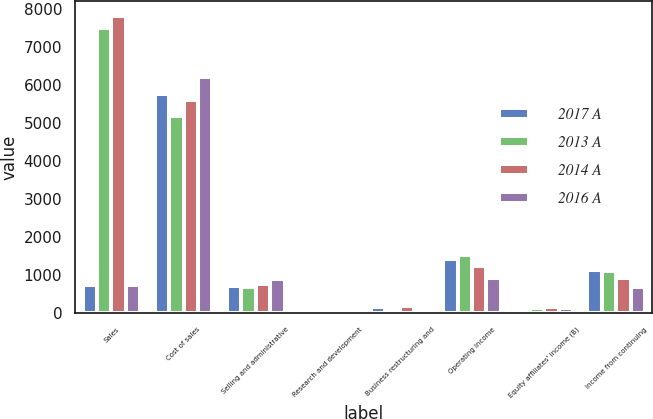Convert chart to OTSL. <chart><loc_0><loc_0><loc_500><loc_500><stacked_bar_chart><ecel><fcel>Sales<fcel>Cost of sales<fcel>Selling and administrative<fcel>Research and development<fcel>Business restructuring and<fcel>Operating income<fcel>Equity affiliates' income (B)<fcel>Income from continuing<nl><fcel>2017 A<fcel>744.5<fcel>5753<fcel>716<fcel>58<fcel>151<fcel>1428<fcel>80<fcel>1134<nl><fcel>2013 A<fcel>7504<fcel>5177<fcel>685<fcel>72<fcel>35<fcel>1530<fcel>147<fcel>1100<nl><fcel>2014 A<fcel>7824<fcel>5598<fcel>773<fcel>76<fcel>180<fcel>1233<fcel>152<fcel>933<nl><fcel>2016 A<fcel>744.5<fcel>6208<fcel>892<fcel>79<fcel>11<fcel>924<fcel>149<fcel>697<nl></chart> 